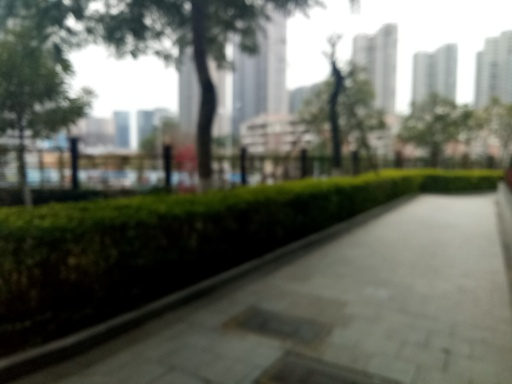What time of day does this image seem to depict, judging by the lighting and shadows? The diffuse lighting in the image suggests it could be on an overcast day or during the early morning or late afternoon when the sun is not at its peak brightness. 